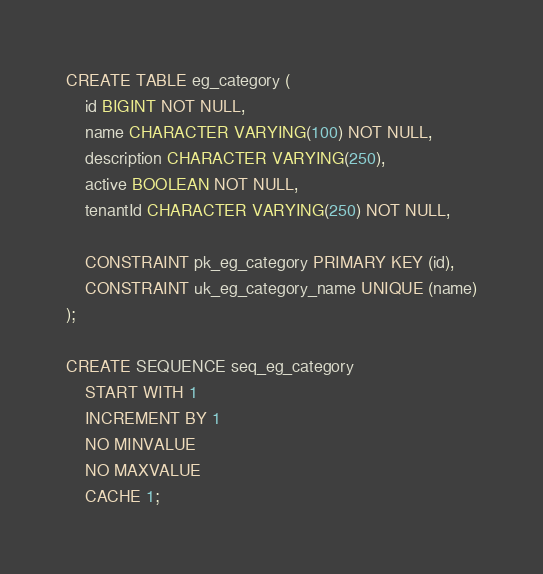<code> <loc_0><loc_0><loc_500><loc_500><_SQL_>CREATE TABLE eg_category (
	id BIGINT NOT NULL,
	name CHARACTER VARYING(100) NOT NULL,
	description CHARACTER VARYING(250),
	active BOOLEAN NOT NULL,
	tenantId CHARACTER VARYING(250) NOT NULL,

	CONSTRAINT pk_eg_category PRIMARY KEY (id),
	CONSTRAINT uk_eg_category_name UNIQUE (name)
);

CREATE SEQUENCE seq_eg_category
    START WITH 1
    INCREMENT BY 1
    NO MINVALUE
    NO MAXVALUE
    CACHE 1;</code> 